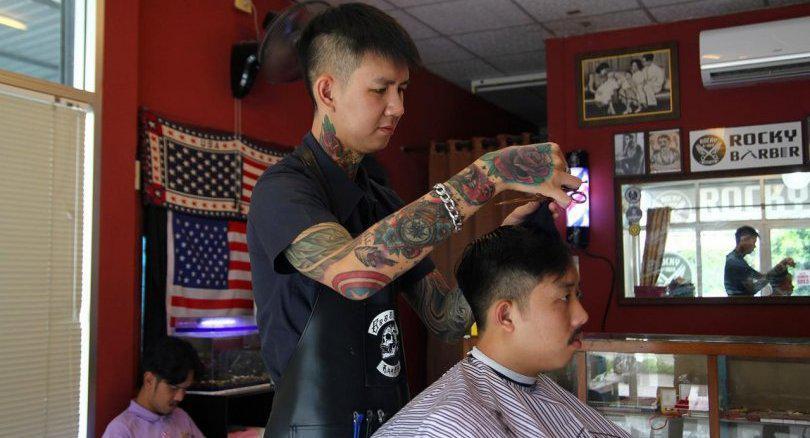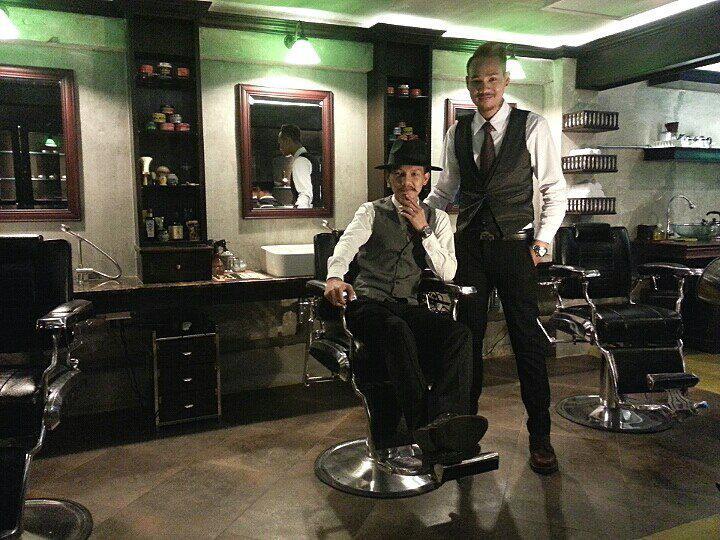The first image is the image on the left, the second image is the image on the right. Examine the images to the left and right. Is the description "Five humans are visible." accurate? Answer yes or no. Yes. 